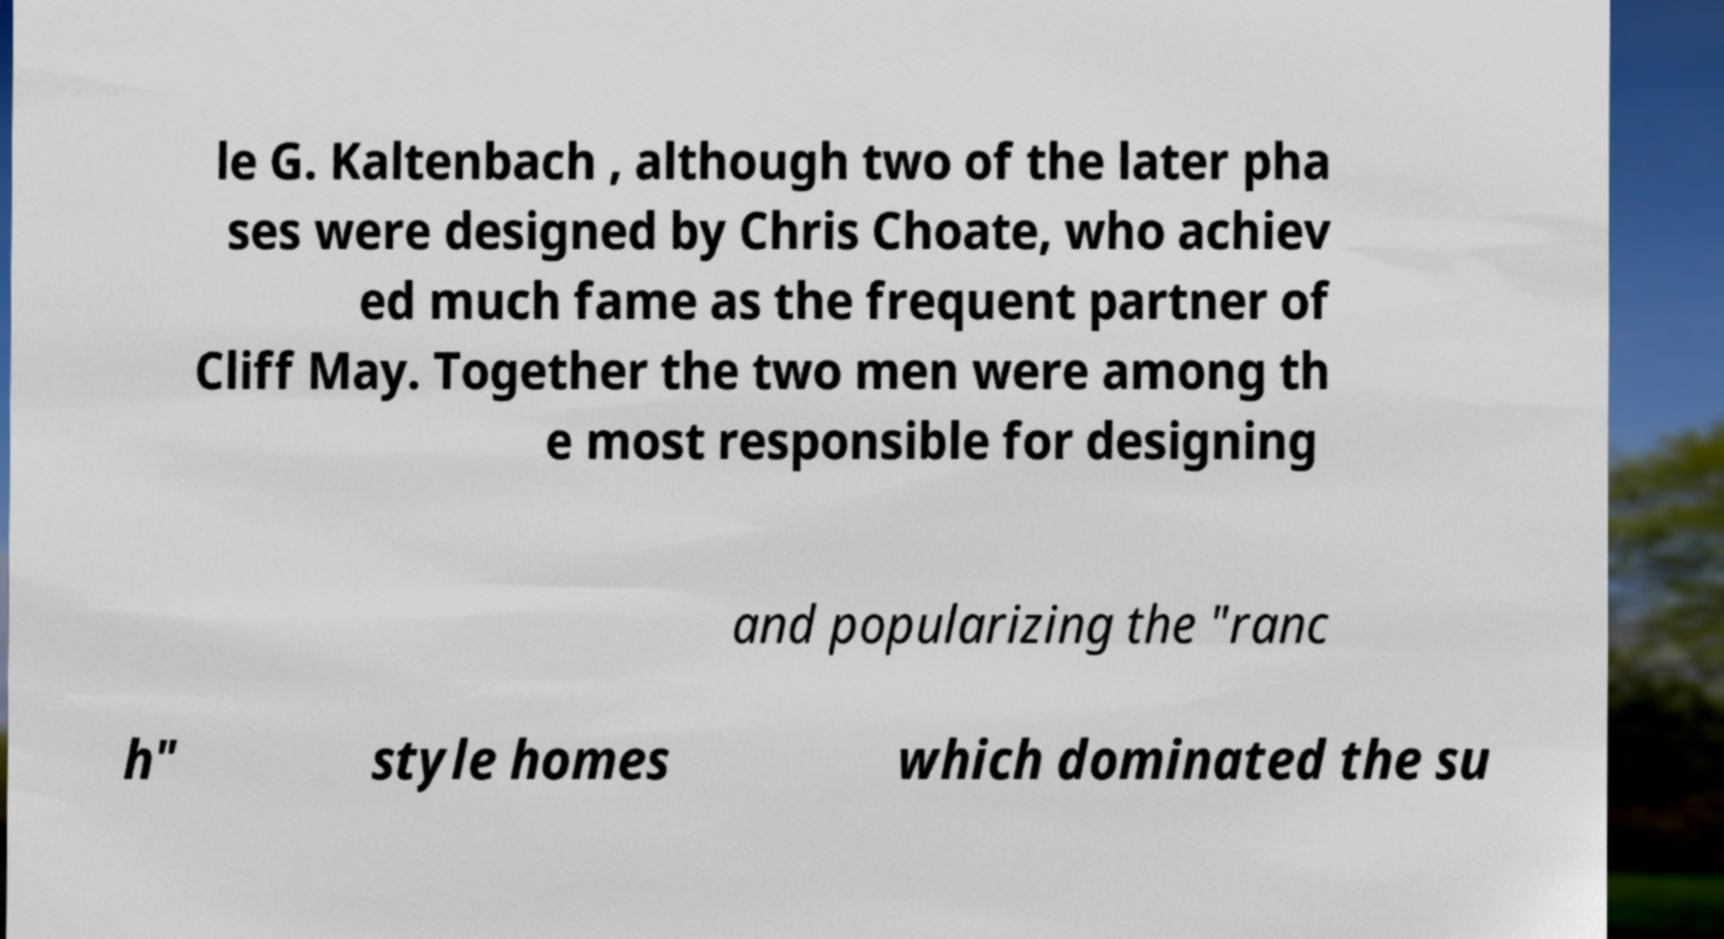Please read and relay the text visible in this image. What does it say? le G. Kaltenbach , although two of the later pha ses were designed by Chris Choate, who achiev ed much fame as the frequent partner of Cliff May. Together the two men were among th e most responsible for designing and popularizing the "ranc h" style homes which dominated the su 